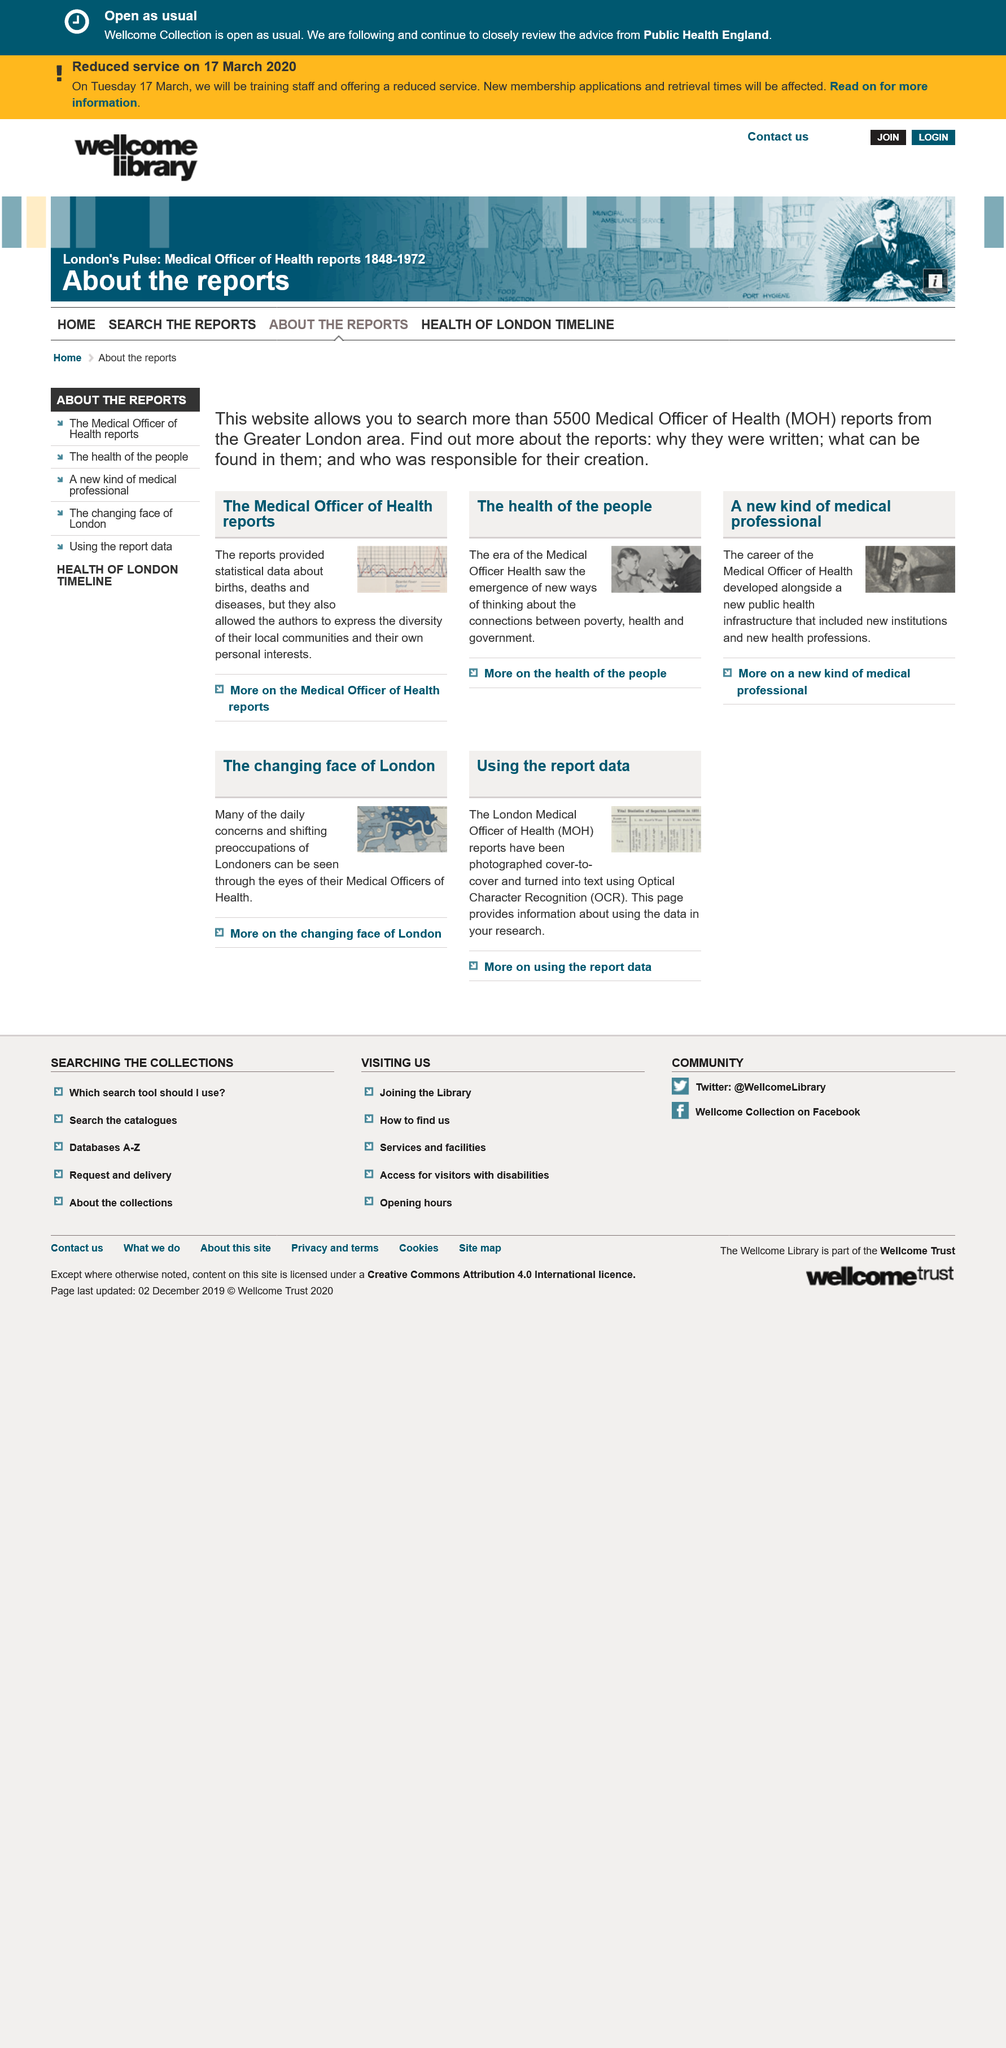Identify some key points in this picture. The Medical Officer of Health reports, the health of the people, and a new kind of medical professional, are the three titles. The Medical Officer of Health's reports provided statistical data about births, deaths, and diseases. The career of the Medical Officer of Health developed alongside a new public health infrastructure that included new institutions and new health professors, as evidenced by the written text "What is written under A new kind of medical professional? 